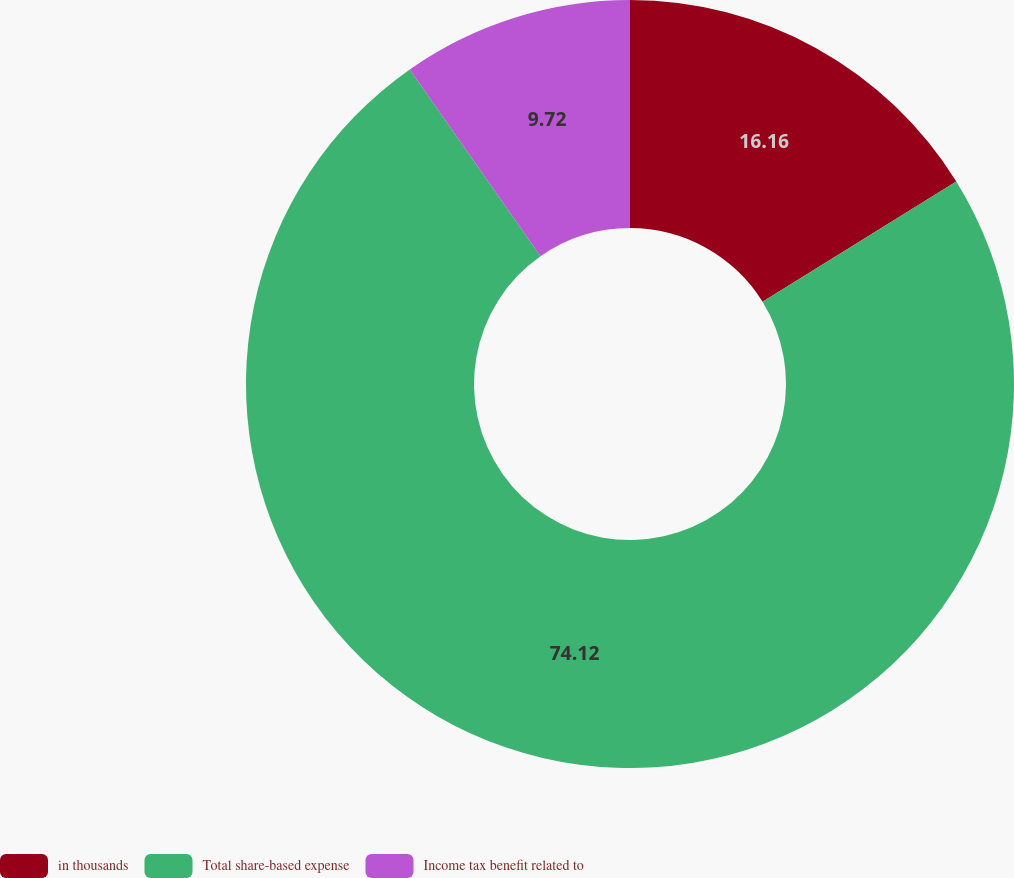Convert chart. <chart><loc_0><loc_0><loc_500><loc_500><pie_chart><fcel>in thousands<fcel>Total share-based expense<fcel>Income tax benefit related to<nl><fcel>16.16%<fcel>74.12%<fcel>9.72%<nl></chart> 